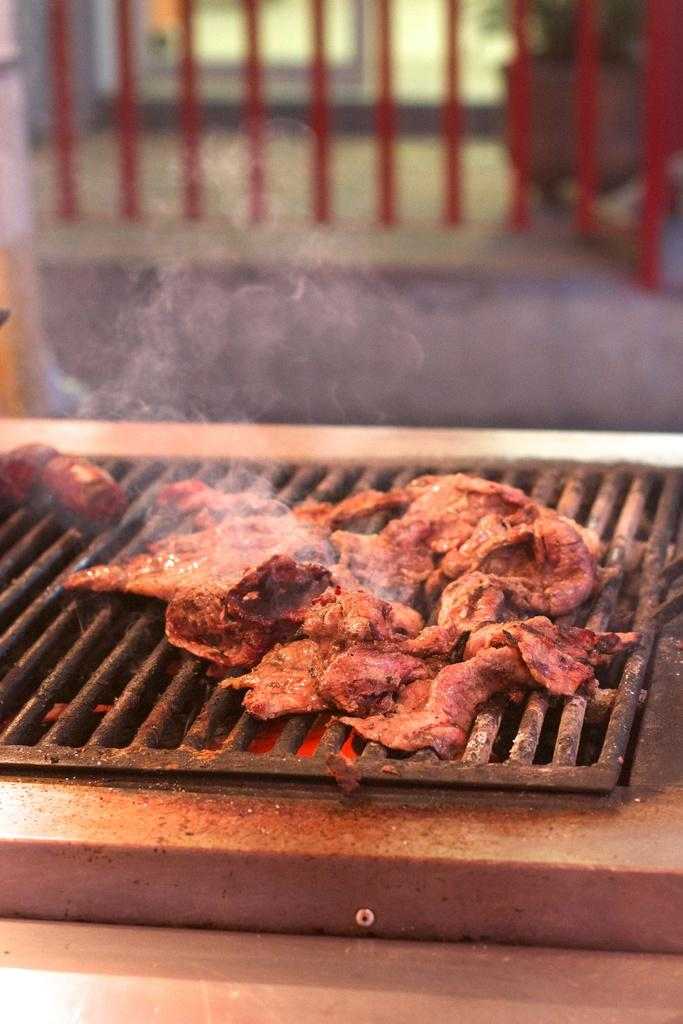What is being cooked on the iron grill in the image? There are meat items on an iron grill in the image. What is the source of heat for cooking the meat items? There is fire present on the iron grill. What type of orange is being used to tie the meat items together in the image? There is no orange present in the image, and the meat items are not tied together. 